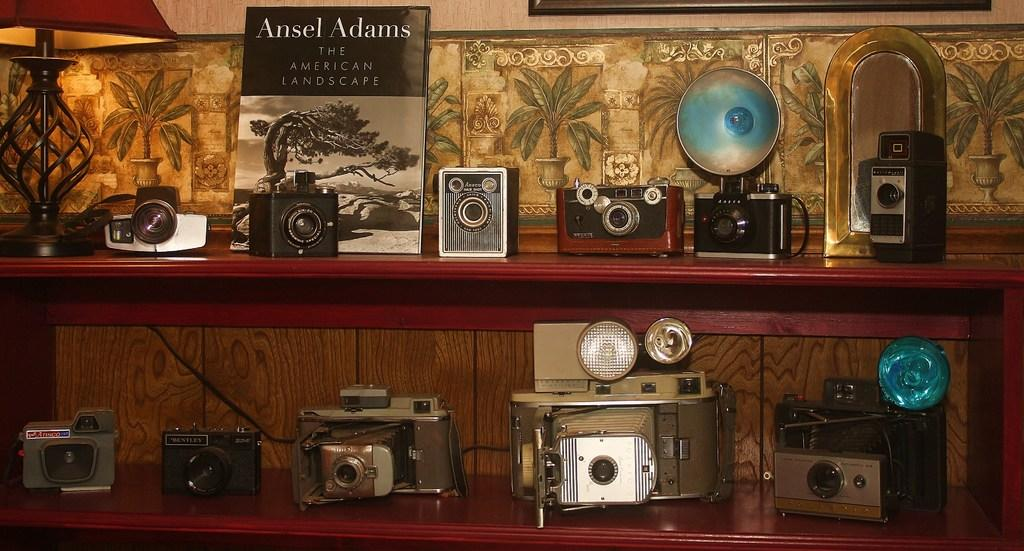<image>
Render a clear and concise summary of the photo. In addition to the collection of cameras a copy of The American Landscape by Ansel Adams. 